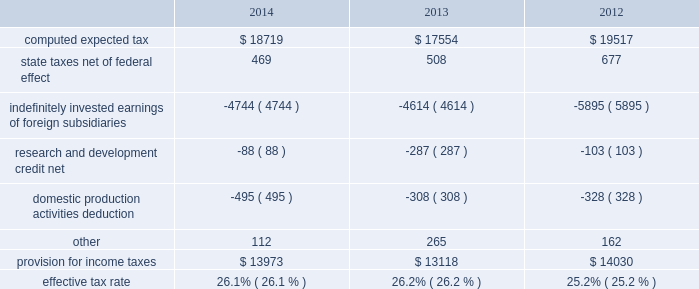Table of contents the foreign provision for income taxes is based on foreign pre-tax earnings of $ 33.6 billion , $ 30.5 billion and $ 36.8 billion in 2014 , 2013 and 2012 , respectively .
The company 2019s consolidated financial statements provide for any related tax liability on undistributed earnings that the company does not intend to be indefinitely reinvested outside the u.s .
Substantially all of the company 2019s undistributed international earnings intended to be indefinitely reinvested in operations outside the u.s .
Were generated by subsidiaries organized in ireland , which has a statutory tax rate of 12.5% ( 12.5 % ) .
As of september 27 , 2014 , u.s .
Income taxes have not been provided on a cumulative total of $ 69.7 billion of such earnings .
The amount of unrecognized deferred tax liability related to these temporary differences is estimated to be approximately $ 23.3 billion .
As of september 27 , 2014 and september 28 , 2013 , $ 137.1 billion and $ 111.3 billion , respectively , of the company 2019s cash , cash equivalents and marketable securities were held by foreign subsidiaries and are generally based in u.s .
Dollar-denominated holdings .
Amounts held by foreign subsidiaries are generally subject to u.s .
Income taxation on repatriation to the u.s .
A reconciliation of the provision for income taxes , with the amount computed by applying the statutory federal income tax rate ( 35% ( 35 % ) in 2014 , 2013 and 2012 ) to income before provision for income taxes for 2014 , 2013 and 2012 , is as follows ( dollars in millions ) : the company 2019s income taxes payable have been reduced by the tax benefits from employee stock plan awards .
For stock options , the company receives an income tax benefit calculated as the tax effect of the difference between the fair market value of the stock issued at the time of the exercise and the exercise price .
For rsus , the company receives an income tax benefit upon the award 2019s vesting equal to the tax effect of the underlying stock 2019s fair market value .
The company had net excess tax benefits from equity awards of $ 706 million , $ 643 million and $ 1.4 billion in 2014 , 2013 and 2012 , respectively , which were reflected as increases to common stock .
Apple inc .
| 2014 form 10-k | 64 .

What was the change in millions in the computed expected tax from 2013 to 2014? 
Computations: (18719 - 17554)
Answer: 1165.0. 